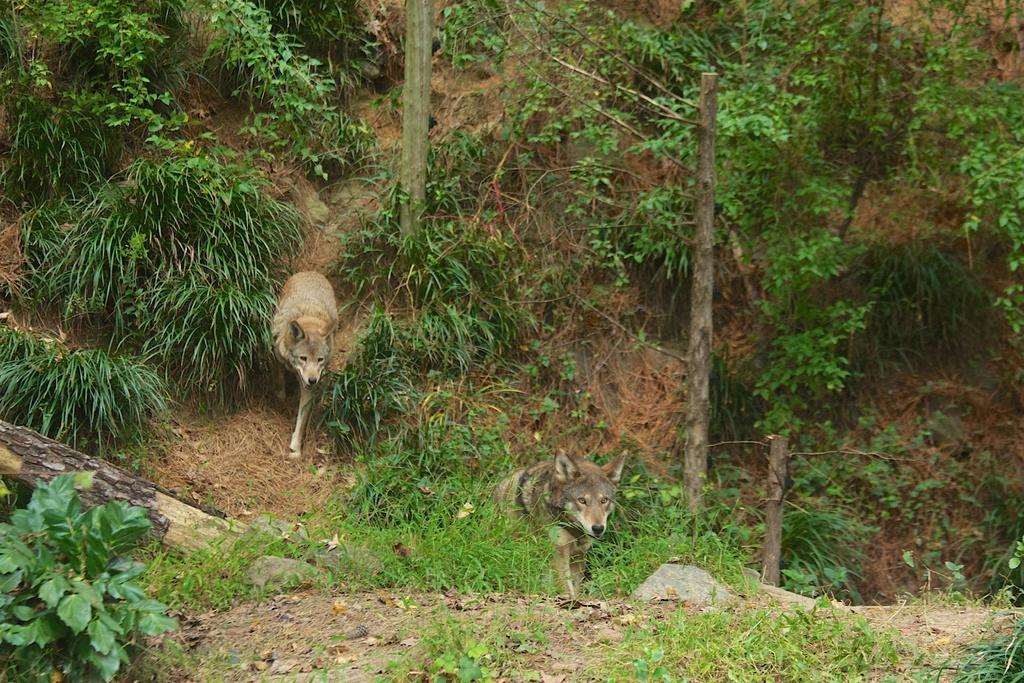What types of living organisms are present in the image? There are two animals in the image. What type of vegetation can be seen in the image? There is grass and plants in the image. What material are the sticks in the image made of? The sticks in the image are made of wood. What is the reason behind the animals' presence in the image? There is no information provided about the reason behind the animals' presence in the image. Can you describe the stem of the plants in the image? There is no mention of stems in the provided facts, and the image does not show any stems. 